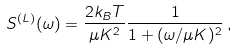Convert formula to latex. <formula><loc_0><loc_0><loc_500><loc_500>S ^ { ( L ) } ( \omega ) = \frac { 2 k _ { B } T } { \mu K ^ { 2 } } \frac { 1 } { 1 + ( \omega / \mu K ) ^ { 2 } } \, ,</formula> 